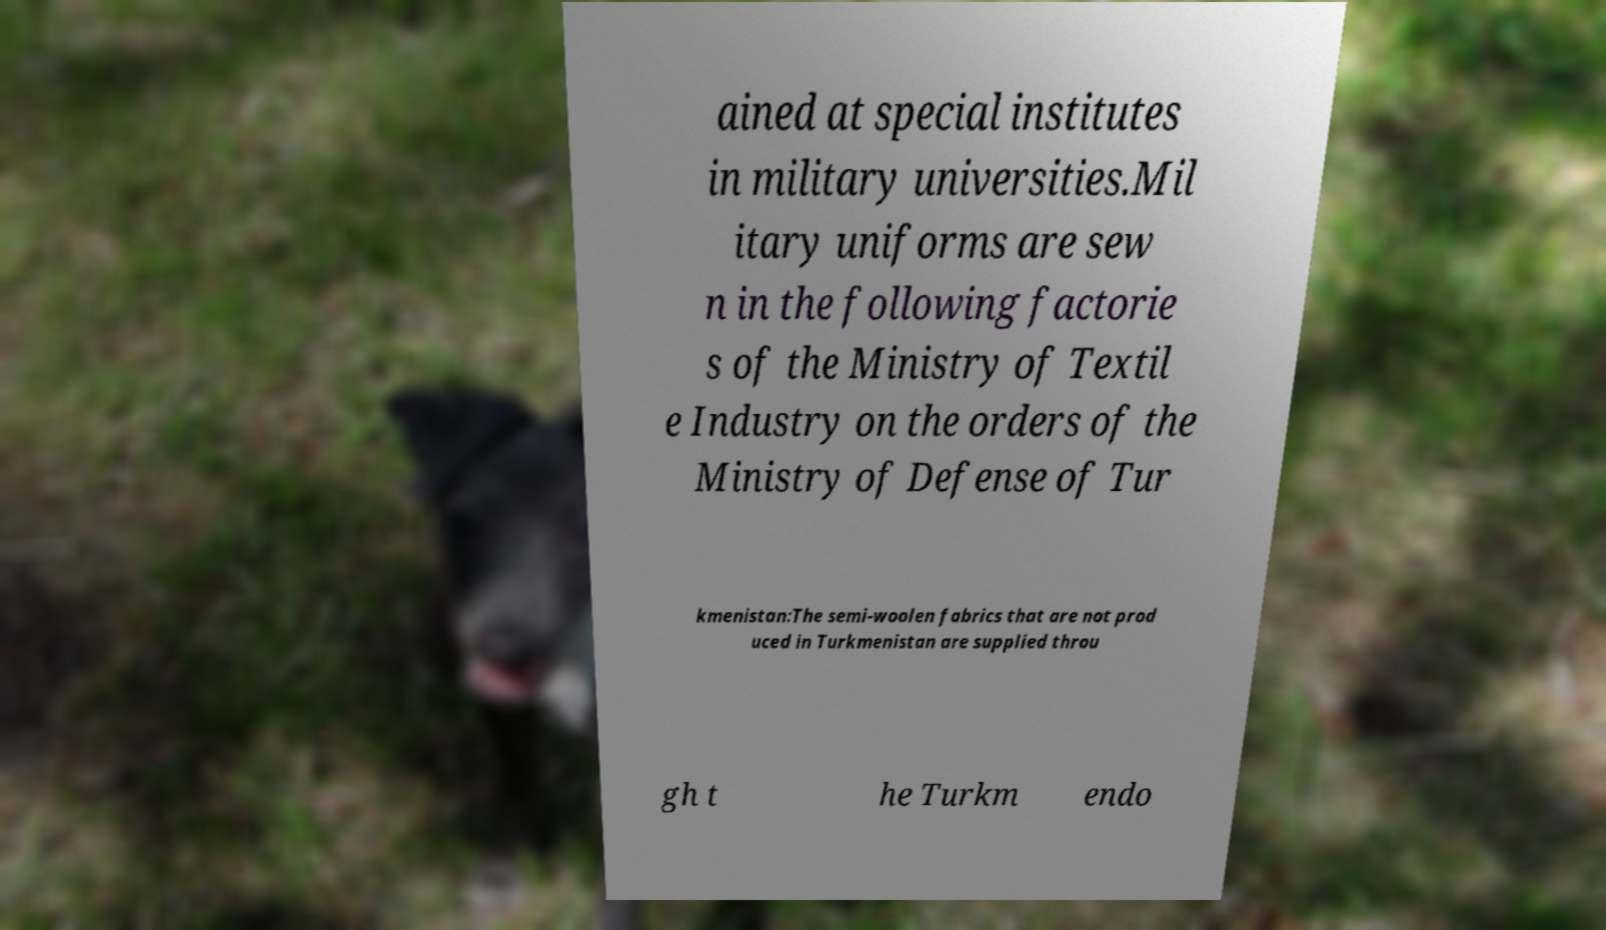Could you assist in decoding the text presented in this image and type it out clearly? ained at special institutes in military universities.Mil itary uniforms are sew n in the following factorie s of the Ministry of Textil e Industry on the orders of the Ministry of Defense of Tur kmenistan:The semi-woolen fabrics that are not prod uced in Turkmenistan are supplied throu gh t he Turkm endo 